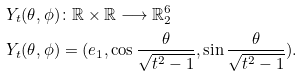Convert formula to latex. <formula><loc_0><loc_0><loc_500><loc_500>Y _ { t } ( \theta , \phi ) & \colon \mathbb { R } \times \mathbb { R } \longrightarrow \mathbb { R } ^ { 6 } _ { 2 } \\ Y _ { t } ( \theta , \phi ) & = ( e _ { 1 } , \cos \frac { \theta } { \sqrt { t ^ { 2 } - 1 } } , \sin \frac { \theta } { \sqrt { t ^ { 2 } - 1 } } ) .</formula> 